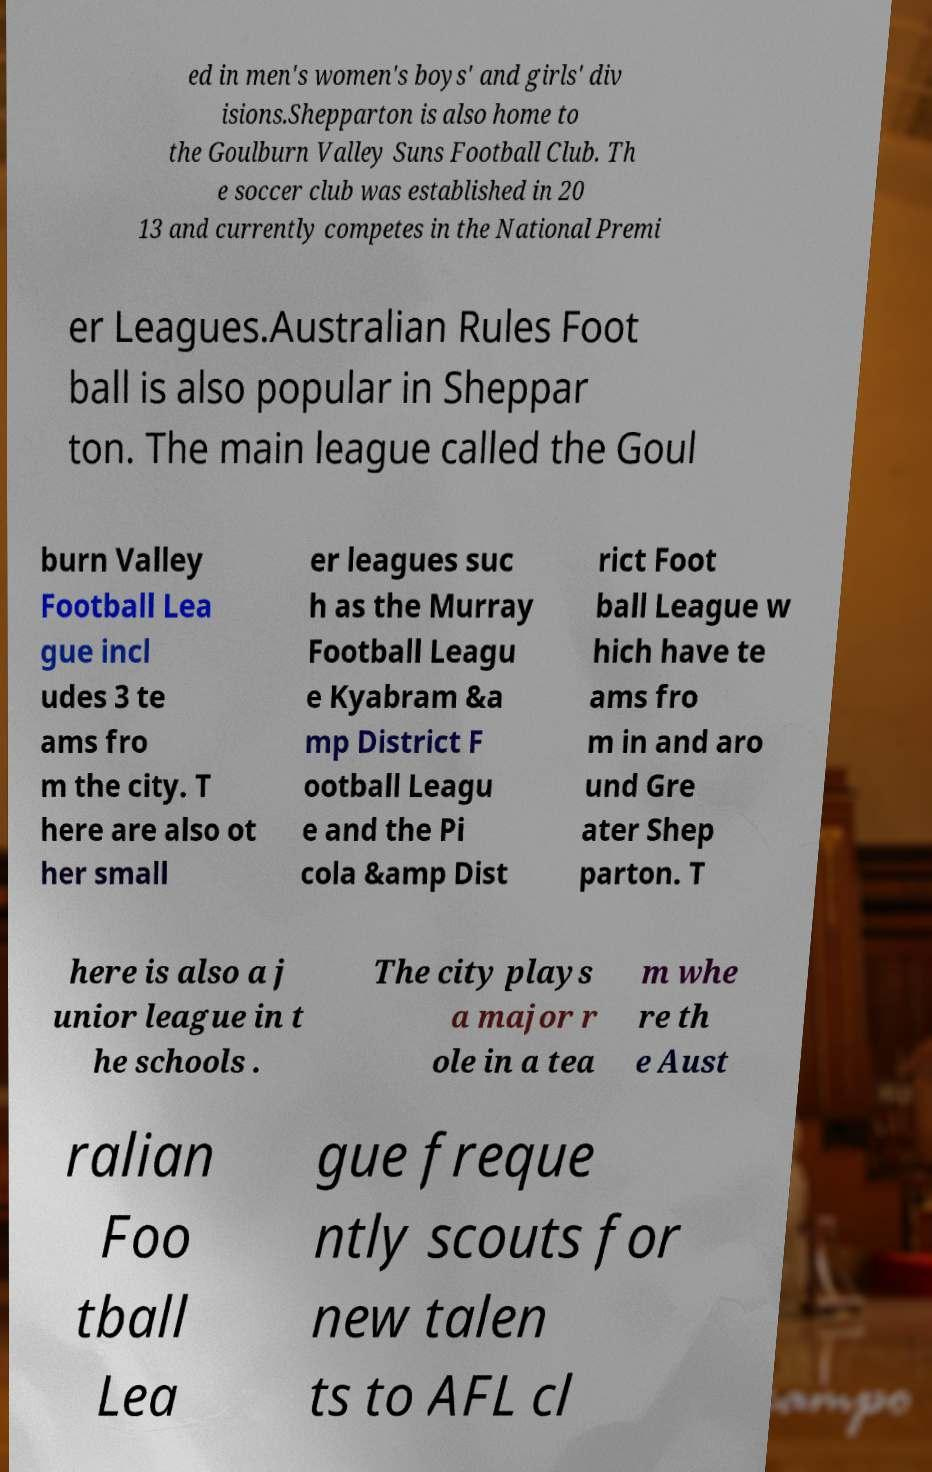Please read and relay the text visible in this image. What does it say? ed in men's women's boys' and girls' div isions.Shepparton is also home to the Goulburn Valley Suns Football Club. Th e soccer club was established in 20 13 and currently competes in the National Premi er Leagues.Australian Rules Foot ball is also popular in Sheppar ton. The main league called the Goul burn Valley Football Lea gue incl udes 3 te ams fro m the city. T here are also ot her small er leagues suc h as the Murray Football Leagu e Kyabram &a mp District F ootball Leagu e and the Pi cola &amp Dist rict Foot ball League w hich have te ams fro m in and aro und Gre ater Shep parton. T here is also a j unior league in t he schools . The city plays a major r ole in a tea m whe re th e Aust ralian Foo tball Lea gue freque ntly scouts for new talen ts to AFL cl 